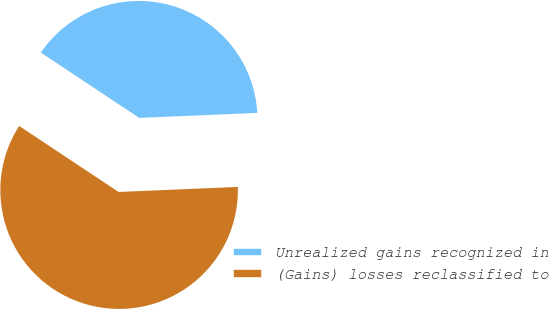Convert chart. <chart><loc_0><loc_0><loc_500><loc_500><pie_chart><fcel>Unrealized gains recognized in<fcel>(Gains) losses reclassified to<nl><fcel>40.0%<fcel>60.0%<nl></chart> 